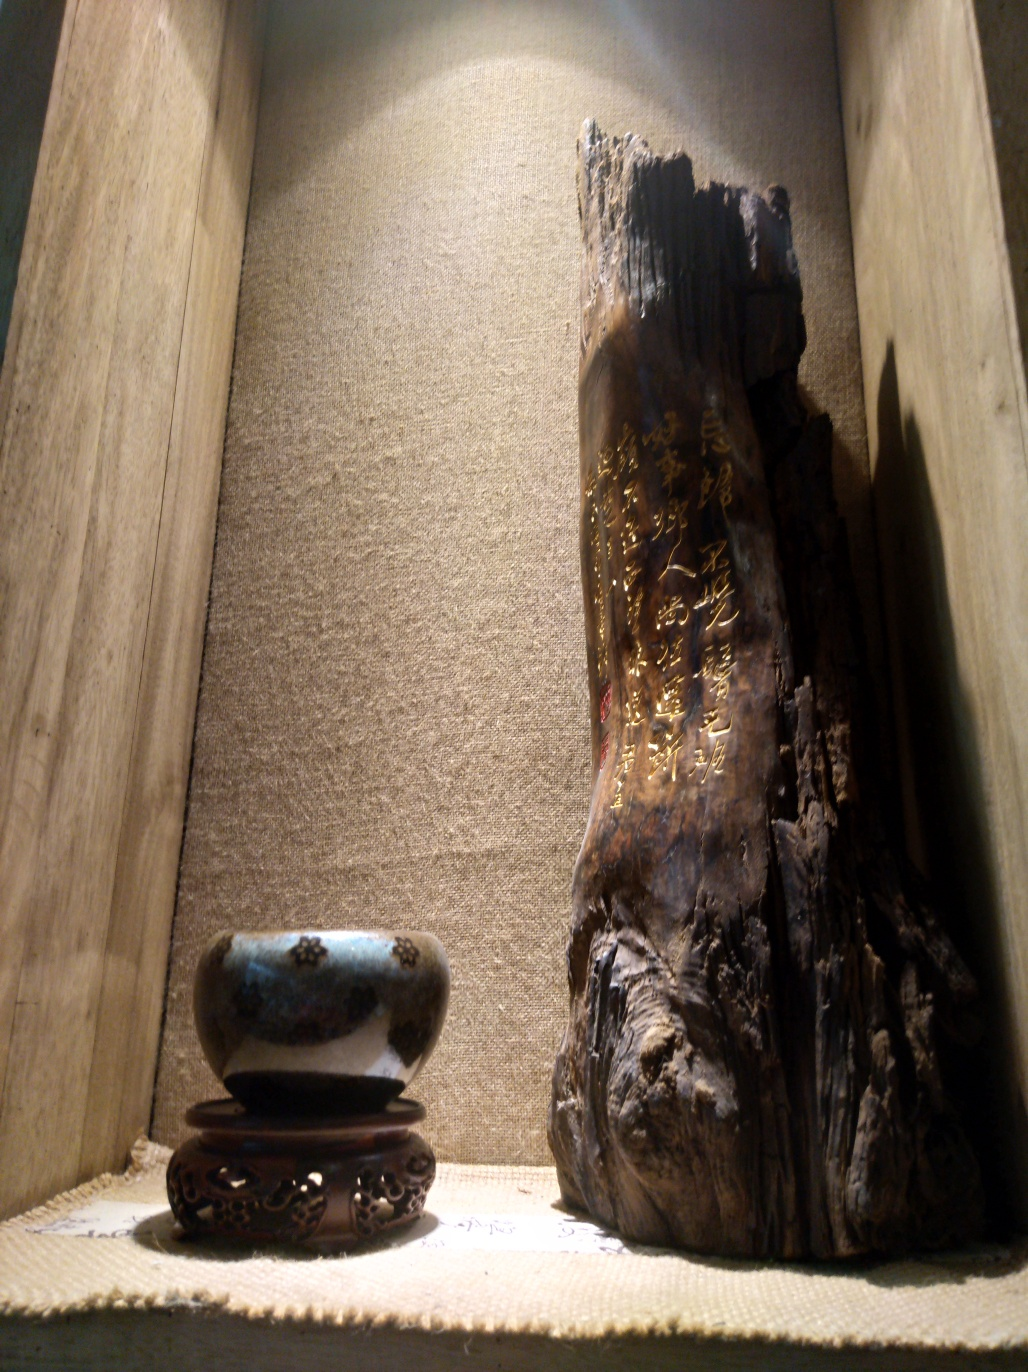How are the details and texture of the bowl and wooden carvings presented? The details and textures of the bowl and wooden carvings are presented quite distinctly. The bowl, resting on an intricately carved stand, exhibits a speckled pattern with varying hues of blue and brown which suggests a unique ceramic glazing technique. As for the wooden carving, the rugged, natural lines of the wood are visible and enhanced by the golden characters etched into the grain. The craftsmanship of both items is showcased effectively by the lighting, highlighting the texture and depth of the pieces. 